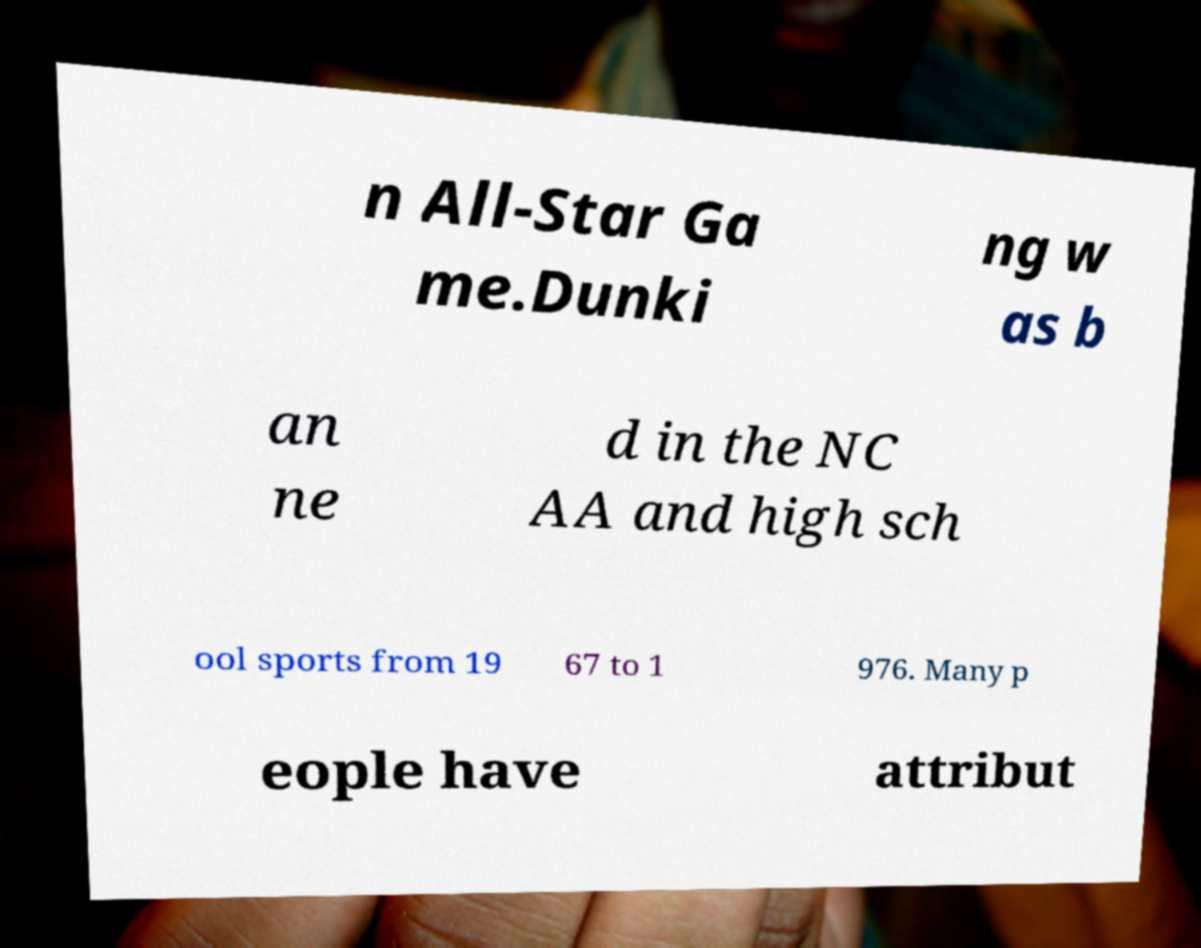Please identify and transcribe the text found in this image. n All-Star Ga me.Dunki ng w as b an ne d in the NC AA and high sch ool sports from 19 67 to 1 976. Many p eople have attribut 